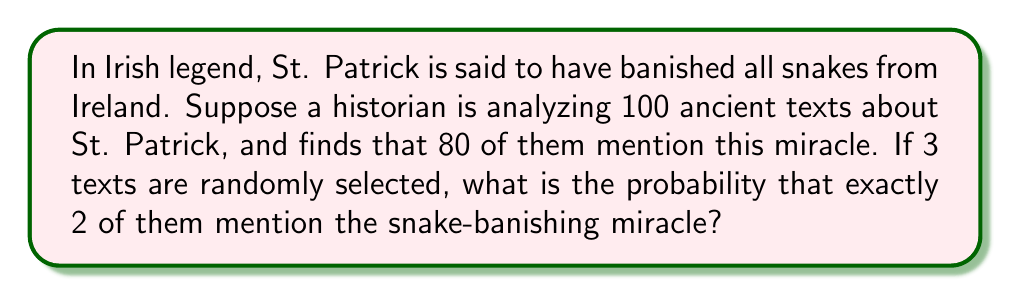Provide a solution to this math problem. To solve this problem, we can use the concept of binomial probability. Let's break it down step-by-step:

1) First, we need to calculate the probability of a single text mentioning the snake-banishing miracle:
   $p = \frac{80}{100} = 0.8$

2) The probability of a text not mentioning the miracle is:
   $q = 1 - p = 1 - 0.8 = 0.2$

3) We want exactly 2 out of 3 texts to mention the miracle. This can be calculated using the binomial probability formula:

   $P(X = k) = \binom{n}{k} p^k q^{n-k}$

   Where:
   $n = 3$ (total number of texts selected)
   $k = 2$ (number of successes we want)
   $p = 0.8$ (probability of success)
   $q = 0.2$ (probability of failure)

4) Let's substitute these values:

   $P(X = 2) = \binom{3}{2} (0.8)^2 (0.2)^{3-2}$

5) Calculate the binomial coefficient:
   $\binom{3}{2} = \frac{3!}{2!(3-2)!} = \frac{3 \cdot 2 \cdot 1}{(2 \cdot 1)(1)} = 3$

6) Now our equation looks like this:
   $P(X = 2) = 3 \cdot (0.8)^2 \cdot (0.2)^1$

7) Let's calculate:
   $P(X = 2) = 3 \cdot 0.64 \cdot 0.2 = 0.384$

Therefore, the probability of exactly 2 out of 3 randomly selected texts mentioning the snake-banishing miracle is 0.384 or 38.4%.
Answer: $0.384$ or $38.4\%$ 